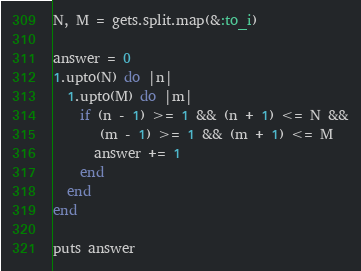<code> <loc_0><loc_0><loc_500><loc_500><_Ruby_>N, M = gets.split.map(&:to_i)

answer = 0
1.upto(N) do |n|
  1.upto(M) do |m|
    if (n - 1) >= 1 && (n + 1) <= N &&
       (m - 1) >= 1 && (m + 1) <= M
      answer += 1
    end
  end
end

puts answer</code> 